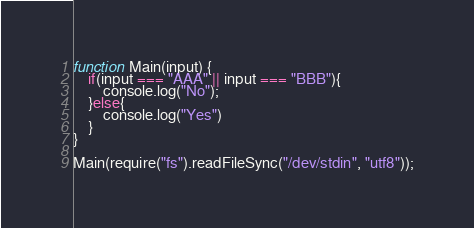<code> <loc_0><loc_0><loc_500><loc_500><_JavaScript_>function Main(input) {
    if(input === "AAA" || input === "BBB"){
        console.log("No");
    }else{
        console.log("Yes")
    }
}

Main(require("fs").readFileSync("/dev/stdin", "utf8"));</code> 